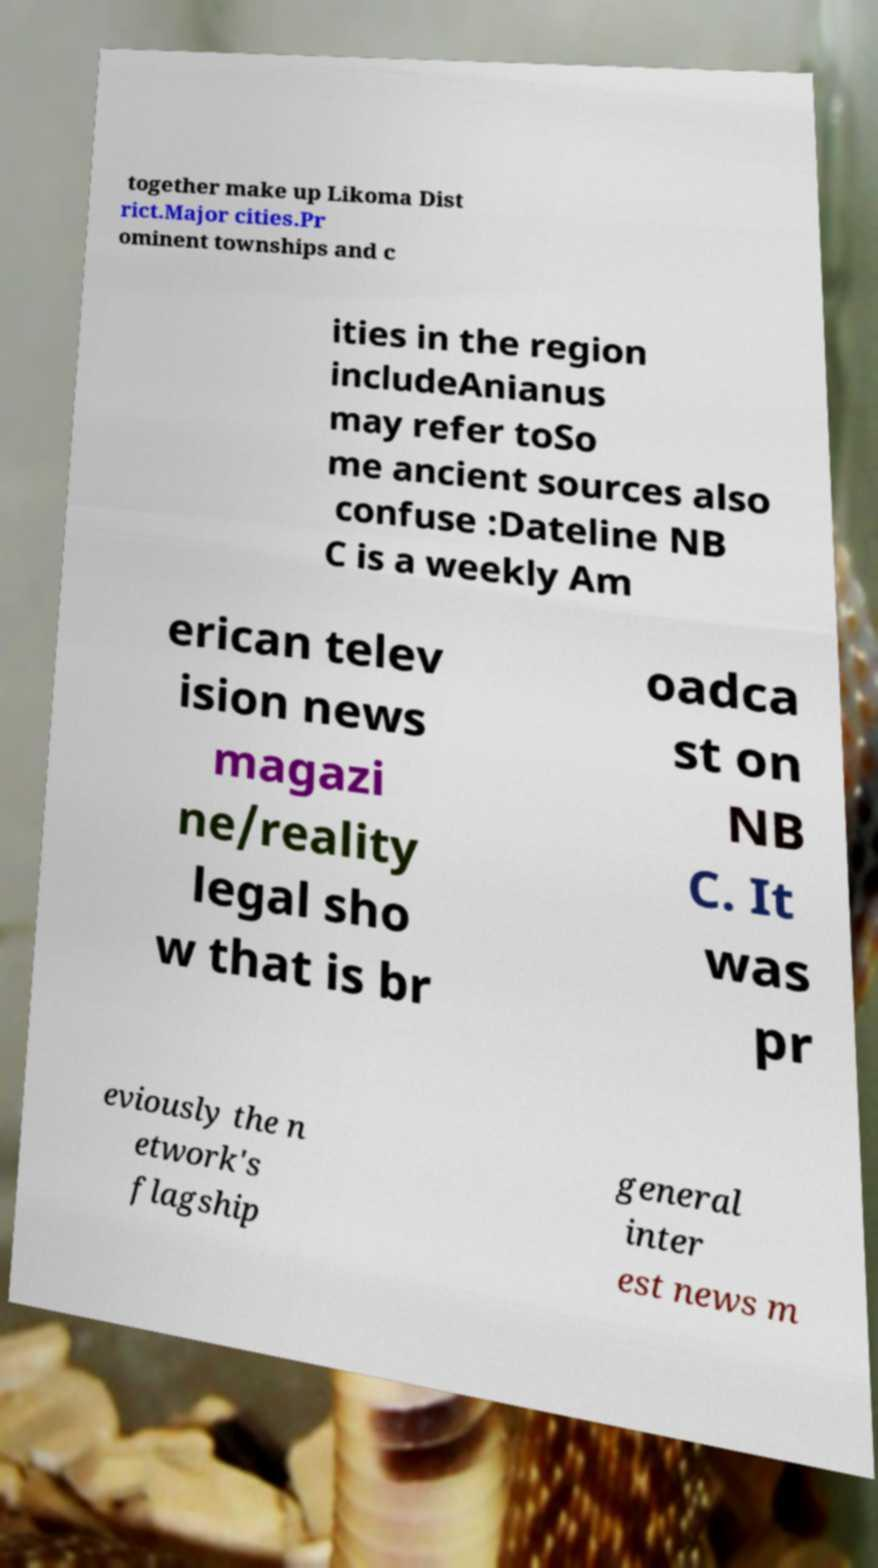Can you accurately transcribe the text from the provided image for me? together make up Likoma Dist rict.Major cities.Pr ominent townships and c ities in the region includeAnianus may refer toSo me ancient sources also confuse :Dateline NB C is a weekly Am erican telev ision news magazi ne/reality legal sho w that is br oadca st on NB C. It was pr eviously the n etwork's flagship general inter est news m 